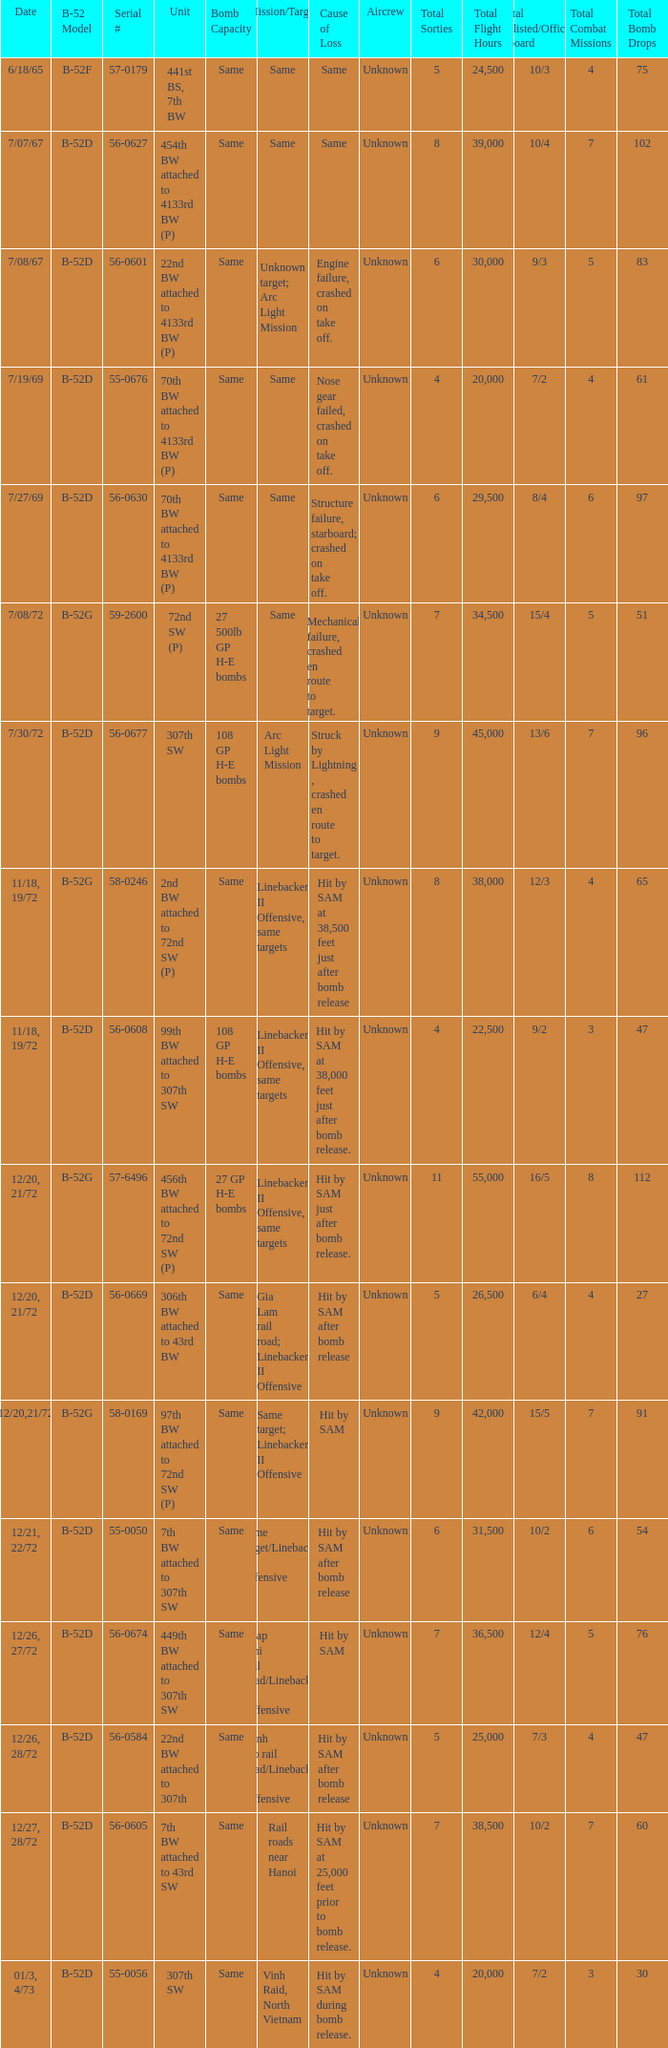When hit by sam at 38,500 feet just after bomb release was the cause of loss what is the mission/target? Linebacker II Offensive, same targets. 